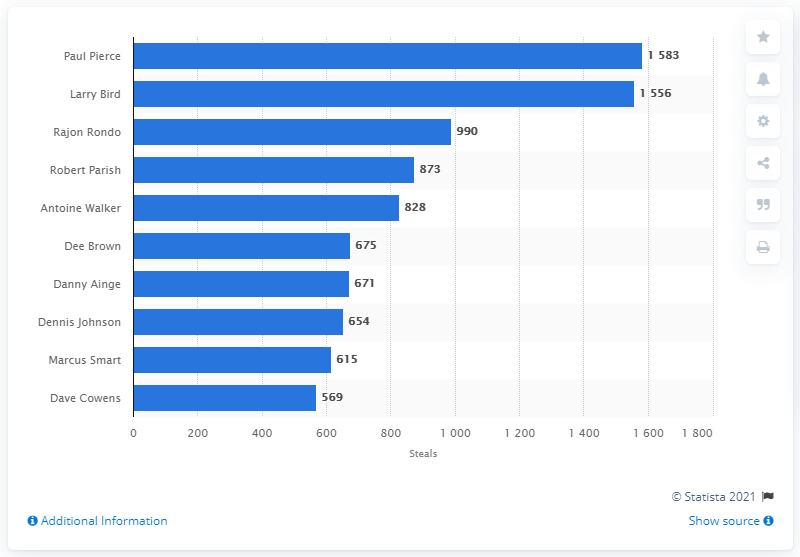Mention a couple of crucial points in this snapshot. Paul Pierce is the career steals leader of the Boston Celtics. 